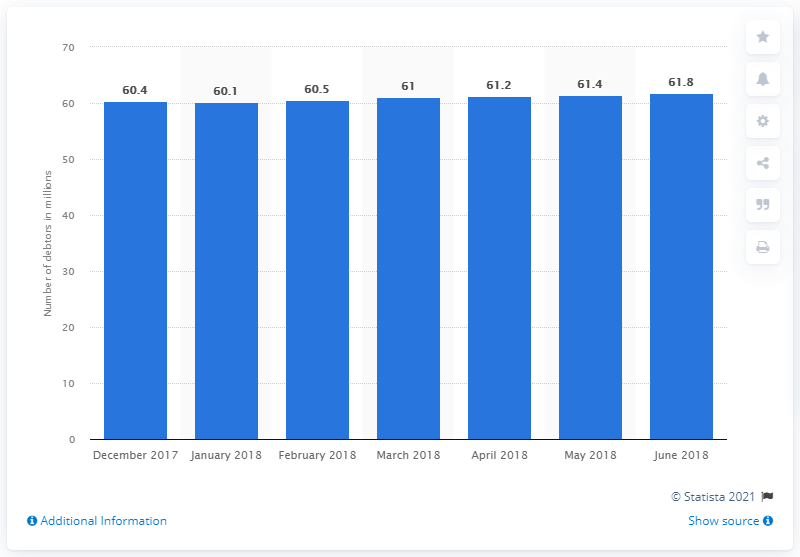Specify some key components in this picture. In December 2017, there were 61 delinquent debtors in Brazil. In June 2018, there were 61.8 delinquent debtors in Brazil. 